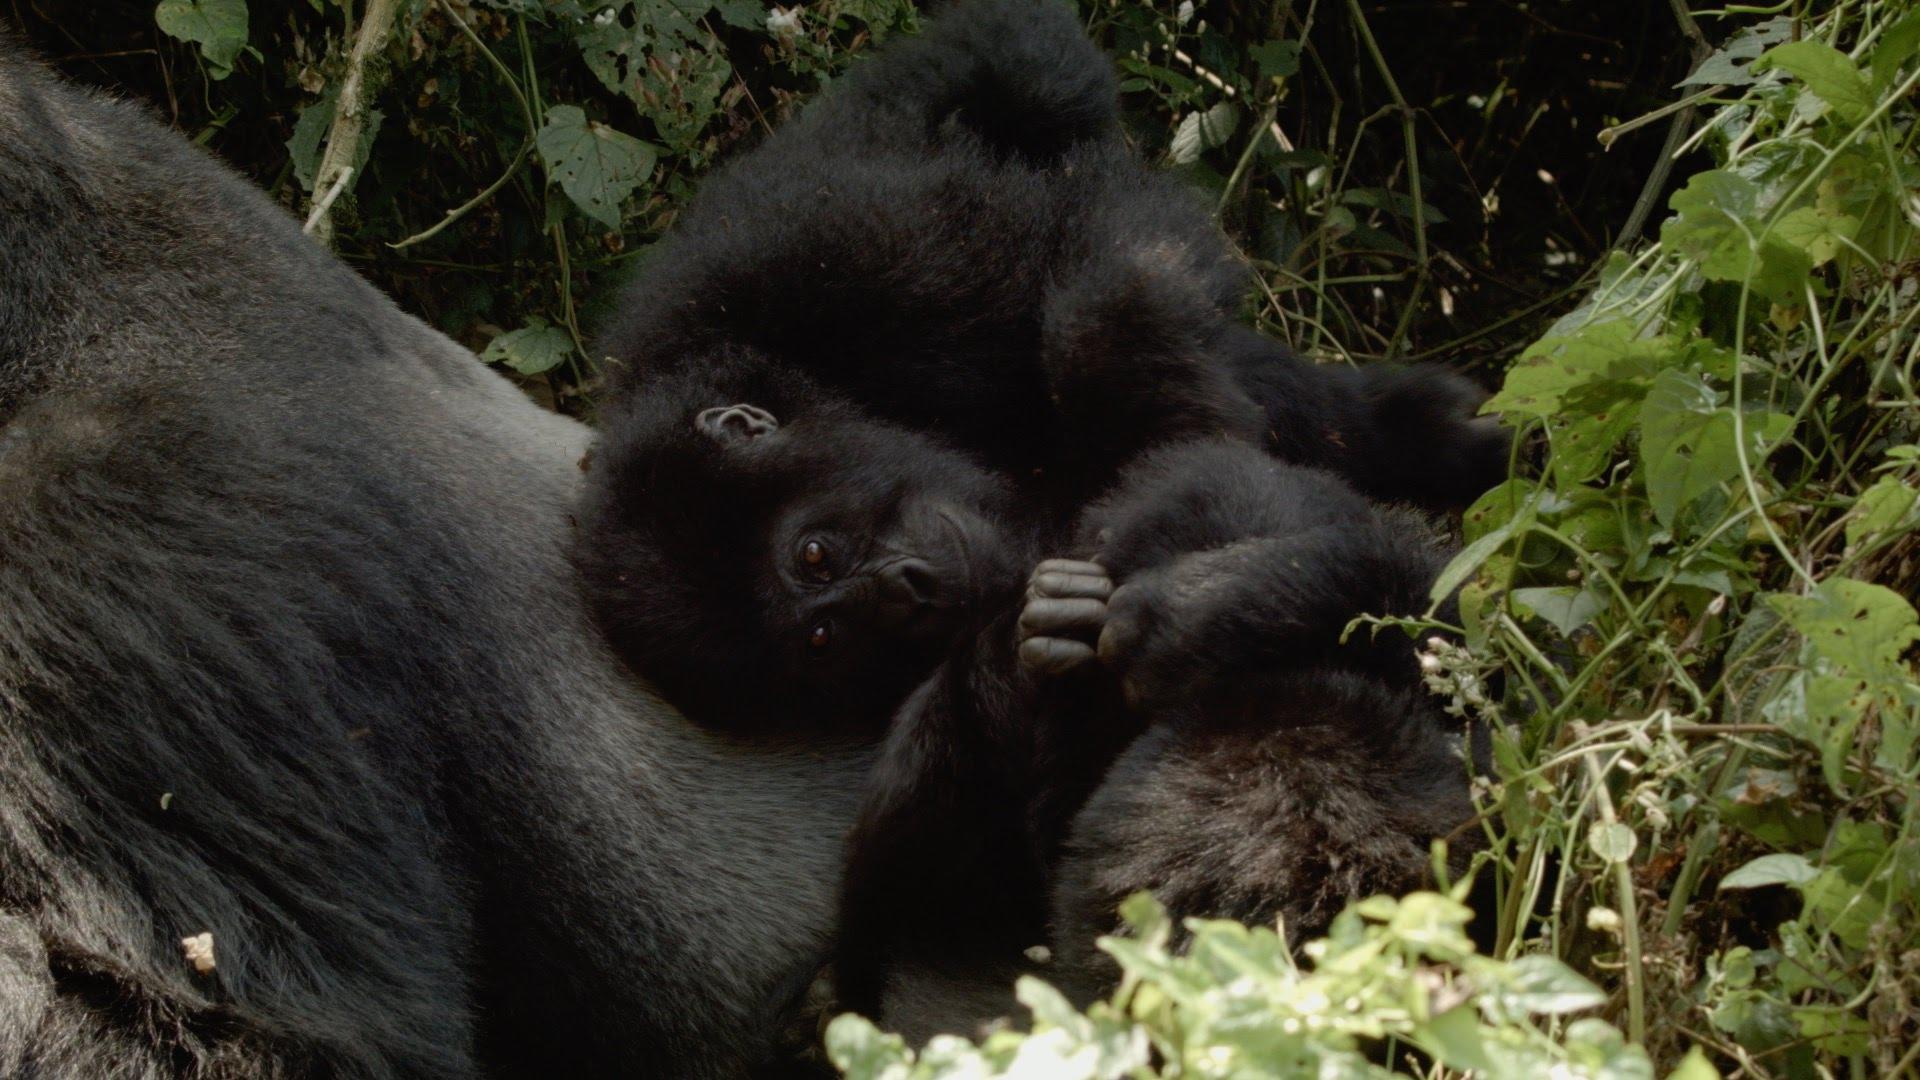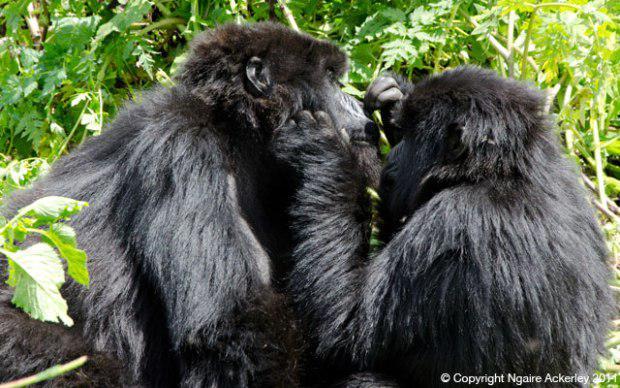The first image is the image on the left, the second image is the image on the right. For the images shown, is this caption "An image contains exactly two gorillas, whose faces are only a few inches apart." true? Answer yes or no. Yes. The first image is the image on the left, the second image is the image on the right. Examine the images to the left and right. Is the description "An adult gorilla is holding a baby gorilla in the right image." accurate? Answer yes or no. No. 